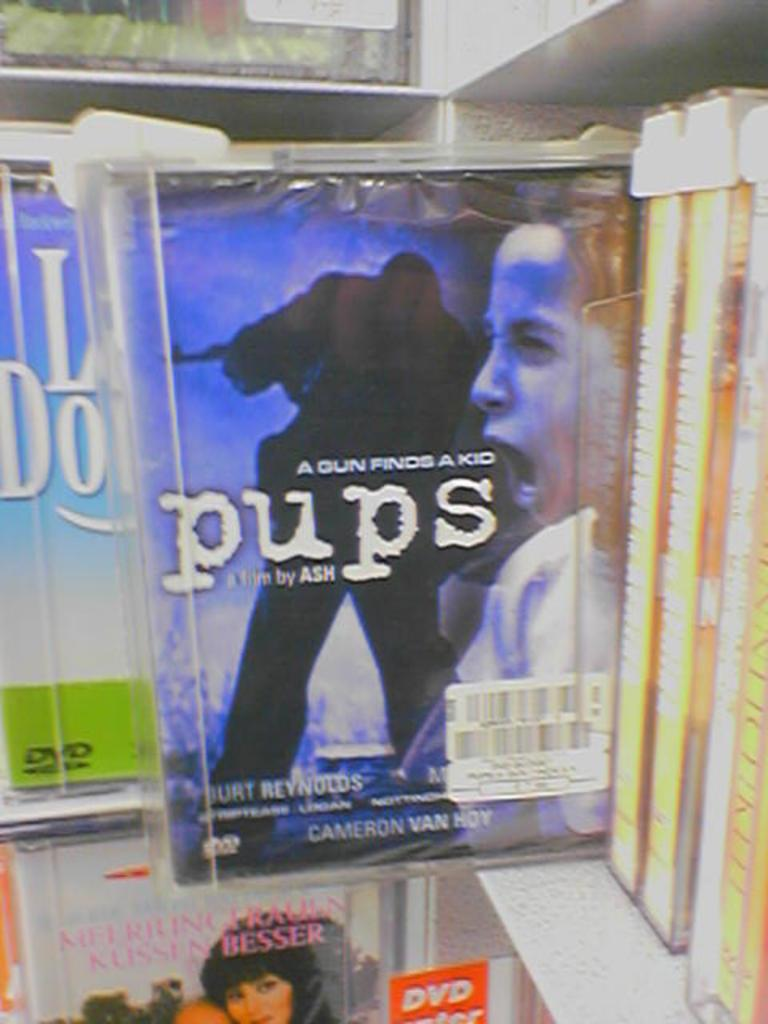<image>
Render a clear and concise summary of the photo. A DVD called Pups a film by Ash is in a security case on a shelf in a store. 